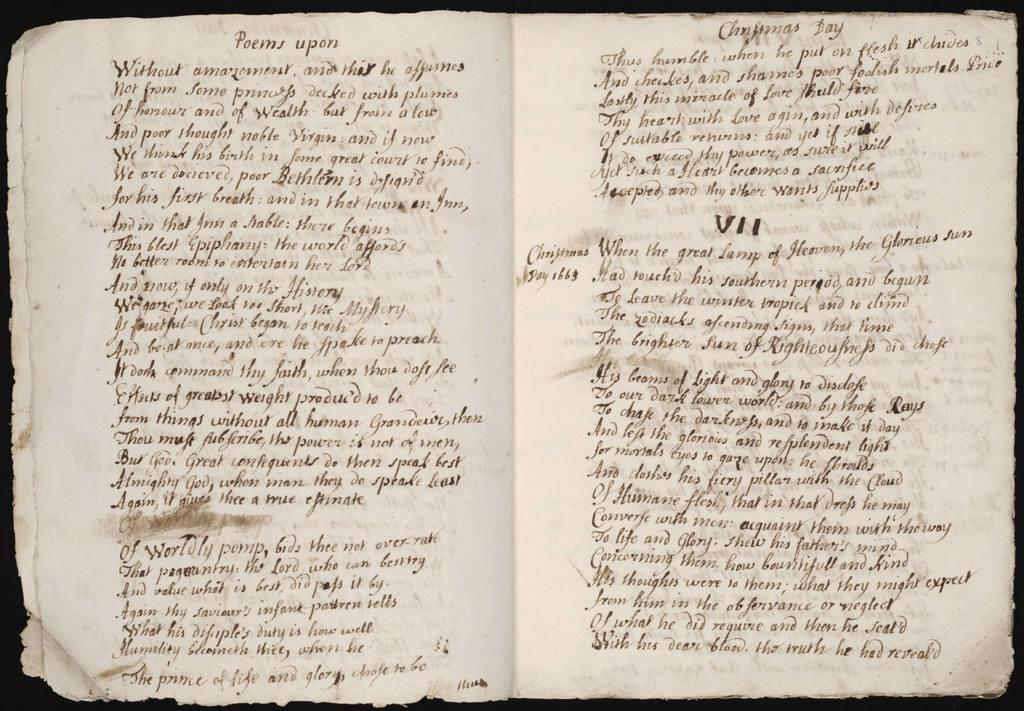<image>
Relay a brief, clear account of the picture shown. An old hand-written book open to chapter VII. 